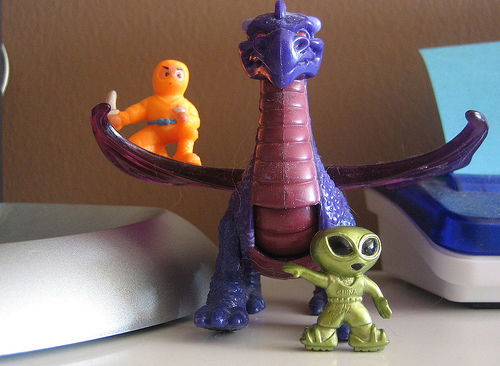<image>
Can you confirm if the ninja toy is above the dragon toy? No. The ninja toy is not positioned above the dragon toy. The vertical arrangement shows a different relationship. 